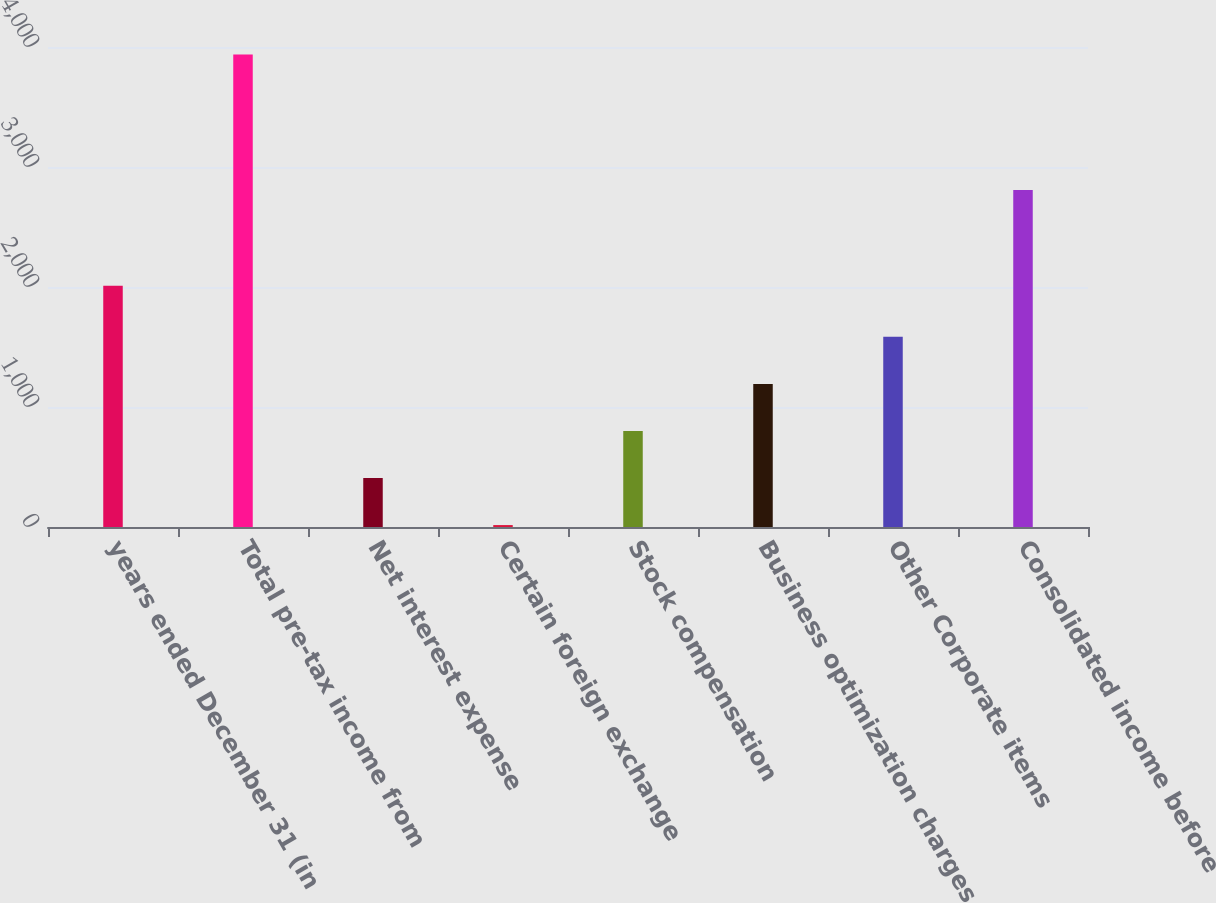<chart> <loc_0><loc_0><loc_500><loc_500><bar_chart><fcel>years ended December 31 (in<fcel>Total pre-tax income from<fcel>Net interest expense<fcel>Certain foreign exchange<fcel>Stock compensation<fcel>Business optimization charges<fcel>Other Corporate items<fcel>Consolidated income before<nl><fcel>2011<fcel>3938<fcel>408.2<fcel>16<fcel>800.4<fcel>1192.6<fcel>1584.8<fcel>2809<nl></chart> 